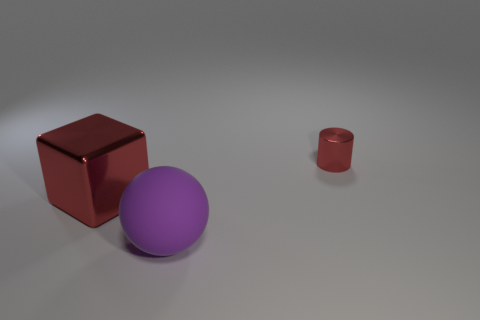How many other things are the same material as the purple ball?
Your response must be concise. 0. How many objects are either green shiny cubes or red shiny things on the right side of the rubber sphere?
Ensure brevity in your answer.  1. Are there fewer metallic things than tiny red metal cylinders?
Make the answer very short. No. The big thing that is on the left side of the large thing on the right side of the red shiny thing to the left of the small red shiny cylinder is what color?
Provide a succinct answer. Red. Is the material of the large purple thing the same as the tiny cylinder?
Ensure brevity in your answer.  No. What number of objects are on the right side of the matte ball?
Provide a succinct answer. 1. How many blue things are either small things or metallic blocks?
Make the answer very short. 0. What number of purple objects are on the right side of the object on the left side of the big purple sphere?
Provide a short and direct response. 1. How many other objects are the same shape as the tiny metal thing?
Keep it short and to the point. 0. There is a big thing that is the same color as the tiny cylinder; what is its material?
Your response must be concise. Metal. 